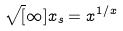Convert formula to latex. <formula><loc_0><loc_0><loc_500><loc_500>\sqrt { [ } \infty ] { x } _ { s } = x ^ { 1 / x }</formula> 